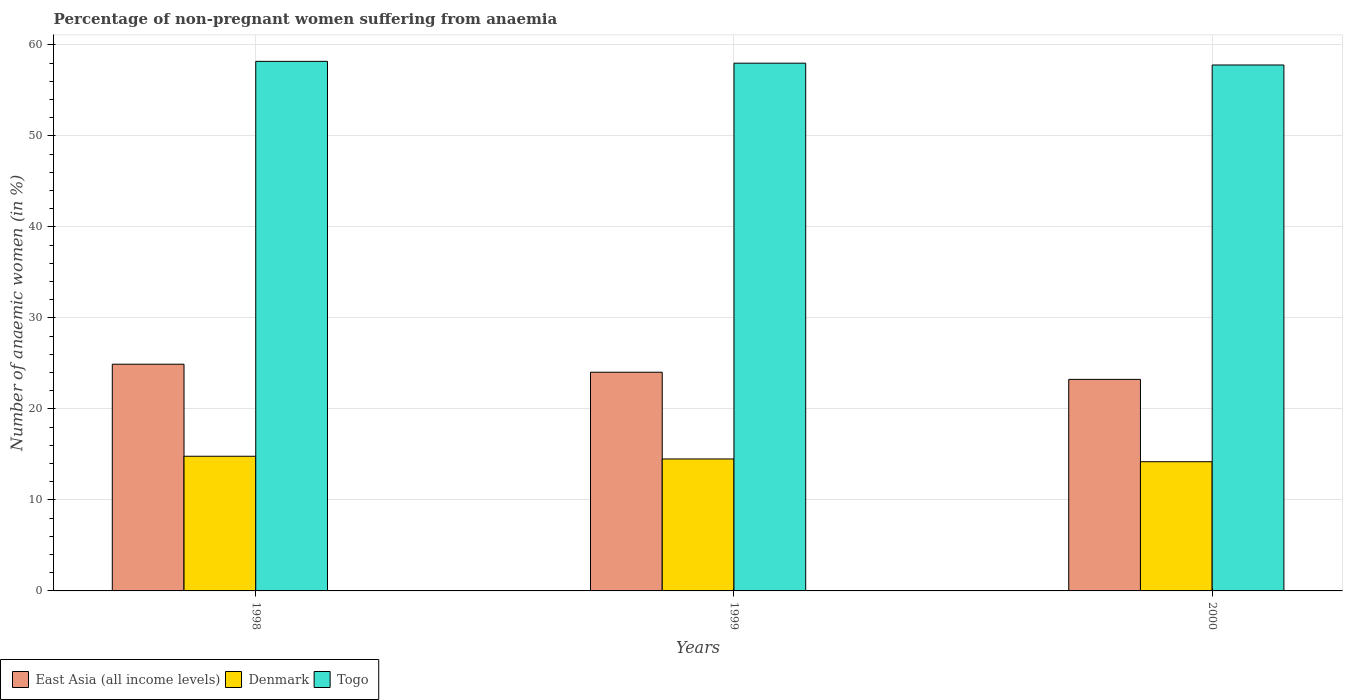How many different coloured bars are there?
Offer a very short reply. 3. How many groups of bars are there?
Your answer should be compact. 3. How many bars are there on the 3rd tick from the left?
Provide a succinct answer. 3. How many bars are there on the 1st tick from the right?
Provide a succinct answer. 3. In how many cases, is the number of bars for a given year not equal to the number of legend labels?
Your response must be concise. 0. What is the percentage of non-pregnant women suffering from anaemia in Togo in 1998?
Make the answer very short. 58.2. Across all years, what is the maximum percentage of non-pregnant women suffering from anaemia in Togo?
Give a very brief answer. 58.2. Across all years, what is the minimum percentage of non-pregnant women suffering from anaemia in East Asia (all income levels)?
Provide a succinct answer. 23.25. In which year was the percentage of non-pregnant women suffering from anaemia in East Asia (all income levels) maximum?
Give a very brief answer. 1998. What is the total percentage of non-pregnant women suffering from anaemia in East Asia (all income levels) in the graph?
Provide a short and direct response. 72.2. What is the difference between the percentage of non-pregnant women suffering from anaemia in Togo in 1998 and that in 2000?
Keep it short and to the point. 0.4. What is the difference between the percentage of non-pregnant women suffering from anaemia in Togo in 1998 and the percentage of non-pregnant women suffering from anaemia in Denmark in 1999?
Make the answer very short. 43.7. What is the average percentage of non-pregnant women suffering from anaemia in East Asia (all income levels) per year?
Your answer should be very brief. 24.07. In the year 1999, what is the difference between the percentage of non-pregnant women suffering from anaemia in Denmark and percentage of non-pregnant women suffering from anaemia in East Asia (all income levels)?
Ensure brevity in your answer.  -9.53. What is the ratio of the percentage of non-pregnant women suffering from anaemia in Togo in 1998 to that in 2000?
Offer a very short reply. 1.01. Is the difference between the percentage of non-pregnant women suffering from anaemia in Denmark in 1998 and 2000 greater than the difference between the percentage of non-pregnant women suffering from anaemia in East Asia (all income levels) in 1998 and 2000?
Keep it short and to the point. No. What is the difference between the highest and the second highest percentage of non-pregnant women suffering from anaemia in Denmark?
Provide a short and direct response. 0.3. What is the difference between the highest and the lowest percentage of non-pregnant women suffering from anaemia in Denmark?
Your answer should be very brief. 0.6. In how many years, is the percentage of non-pregnant women suffering from anaemia in East Asia (all income levels) greater than the average percentage of non-pregnant women suffering from anaemia in East Asia (all income levels) taken over all years?
Provide a short and direct response. 1. What does the 3rd bar from the left in 1998 represents?
Ensure brevity in your answer.  Togo. What does the 1st bar from the right in 1998 represents?
Offer a very short reply. Togo. How many bars are there?
Your answer should be compact. 9. Are all the bars in the graph horizontal?
Your response must be concise. No. How many years are there in the graph?
Provide a succinct answer. 3. What is the difference between two consecutive major ticks on the Y-axis?
Provide a succinct answer. 10. Does the graph contain any zero values?
Offer a terse response. No. Does the graph contain grids?
Offer a terse response. Yes. How many legend labels are there?
Ensure brevity in your answer.  3. What is the title of the graph?
Keep it short and to the point. Percentage of non-pregnant women suffering from anaemia. What is the label or title of the X-axis?
Ensure brevity in your answer.  Years. What is the label or title of the Y-axis?
Offer a very short reply. Number of anaemic women (in %). What is the Number of anaemic women (in %) in East Asia (all income levels) in 1998?
Provide a succinct answer. 24.92. What is the Number of anaemic women (in %) of Denmark in 1998?
Your response must be concise. 14.8. What is the Number of anaemic women (in %) in Togo in 1998?
Provide a succinct answer. 58.2. What is the Number of anaemic women (in %) of East Asia (all income levels) in 1999?
Keep it short and to the point. 24.03. What is the Number of anaemic women (in %) of East Asia (all income levels) in 2000?
Ensure brevity in your answer.  23.25. What is the Number of anaemic women (in %) in Denmark in 2000?
Your answer should be very brief. 14.2. What is the Number of anaemic women (in %) of Togo in 2000?
Your response must be concise. 57.8. Across all years, what is the maximum Number of anaemic women (in %) of East Asia (all income levels)?
Your answer should be compact. 24.92. Across all years, what is the maximum Number of anaemic women (in %) of Togo?
Ensure brevity in your answer.  58.2. Across all years, what is the minimum Number of anaemic women (in %) of East Asia (all income levels)?
Your response must be concise. 23.25. Across all years, what is the minimum Number of anaemic women (in %) of Togo?
Ensure brevity in your answer.  57.8. What is the total Number of anaemic women (in %) of East Asia (all income levels) in the graph?
Provide a succinct answer. 72.2. What is the total Number of anaemic women (in %) in Denmark in the graph?
Provide a short and direct response. 43.5. What is the total Number of anaemic women (in %) of Togo in the graph?
Your answer should be very brief. 174. What is the difference between the Number of anaemic women (in %) of East Asia (all income levels) in 1998 and that in 1999?
Provide a short and direct response. 0.88. What is the difference between the Number of anaemic women (in %) of East Asia (all income levels) in 1998 and that in 2000?
Your response must be concise. 1.67. What is the difference between the Number of anaemic women (in %) in Denmark in 1998 and that in 2000?
Provide a succinct answer. 0.6. What is the difference between the Number of anaemic women (in %) in Togo in 1998 and that in 2000?
Give a very brief answer. 0.4. What is the difference between the Number of anaemic women (in %) of East Asia (all income levels) in 1999 and that in 2000?
Offer a terse response. 0.79. What is the difference between the Number of anaemic women (in %) of Togo in 1999 and that in 2000?
Provide a short and direct response. 0.2. What is the difference between the Number of anaemic women (in %) of East Asia (all income levels) in 1998 and the Number of anaemic women (in %) of Denmark in 1999?
Offer a terse response. 10.42. What is the difference between the Number of anaemic women (in %) of East Asia (all income levels) in 1998 and the Number of anaemic women (in %) of Togo in 1999?
Ensure brevity in your answer.  -33.08. What is the difference between the Number of anaemic women (in %) in Denmark in 1998 and the Number of anaemic women (in %) in Togo in 1999?
Make the answer very short. -43.2. What is the difference between the Number of anaemic women (in %) of East Asia (all income levels) in 1998 and the Number of anaemic women (in %) of Denmark in 2000?
Make the answer very short. 10.72. What is the difference between the Number of anaemic women (in %) of East Asia (all income levels) in 1998 and the Number of anaemic women (in %) of Togo in 2000?
Keep it short and to the point. -32.88. What is the difference between the Number of anaemic women (in %) of Denmark in 1998 and the Number of anaemic women (in %) of Togo in 2000?
Keep it short and to the point. -43. What is the difference between the Number of anaemic women (in %) of East Asia (all income levels) in 1999 and the Number of anaemic women (in %) of Denmark in 2000?
Make the answer very short. 9.83. What is the difference between the Number of anaemic women (in %) of East Asia (all income levels) in 1999 and the Number of anaemic women (in %) of Togo in 2000?
Provide a succinct answer. -33.77. What is the difference between the Number of anaemic women (in %) of Denmark in 1999 and the Number of anaemic women (in %) of Togo in 2000?
Your response must be concise. -43.3. What is the average Number of anaemic women (in %) in East Asia (all income levels) per year?
Offer a very short reply. 24.07. What is the average Number of anaemic women (in %) in Denmark per year?
Your answer should be very brief. 14.5. What is the average Number of anaemic women (in %) in Togo per year?
Your response must be concise. 58. In the year 1998, what is the difference between the Number of anaemic women (in %) of East Asia (all income levels) and Number of anaemic women (in %) of Denmark?
Provide a short and direct response. 10.12. In the year 1998, what is the difference between the Number of anaemic women (in %) in East Asia (all income levels) and Number of anaemic women (in %) in Togo?
Offer a terse response. -33.28. In the year 1998, what is the difference between the Number of anaemic women (in %) of Denmark and Number of anaemic women (in %) of Togo?
Make the answer very short. -43.4. In the year 1999, what is the difference between the Number of anaemic women (in %) of East Asia (all income levels) and Number of anaemic women (in %) of Denmark?
Give a very brief answer. 9.53. In the year 1999, what is the difference between the Number of anaemic women (in %) of East Asia (all income levels) and Number of anaemic women (in %) of Togo?
Offer a terse response. -33.97. In the year 1999, what is the difference between the Number of anaemic women (in %) of Denmark and Number of anaemic women (in %) of Togo?
Give a very brief answer. -43.5. In the year 2000, what is the difference between the Number of anaemic women (in %) of East Asia (all income levels) and Number of anaemic women (in %) of Denmark?
Give a very brief answer. 9.05. In the year 2000, what is the difference between the Number of anaemic women (in %) of East Asia (all income levels) and Number of anaemic women (in %) of Togo?
Your answer should be compact. -34.55. In the year 2000, what is the difference between the Number of anaemic women (in %) of Denmark and Number of anaemic women (in %) of Togo?
Your answer should be compact. -43.6. What is the ratio of the Number of anaemic women (in %) of East Asia (all income levels) in 1998 to that in 1999?
Make the answer very short. 1.04. What is the ratio of the Number of anaemic women (in %) in Denmark in 1998 to that in 1999?
Offer a very short reply. 1.02. What is the ratio of the Number of anaemic women (in %) in East Asia (all income levels) in 1998 to that in 2000?
Your response must be concise. 1.07. What is the ratio of the Number of anaemic women (in %) in Denmark in 1998 to that in 2000?
Your response must be concise. 1.04. What is the ratio of the Number of anaemic women (in %) of East Asia (all income levels) in 1999 to that in 2000?
Provide a short and direct response. 1.03. What is the ratio of the Number of anaemic women (in %) of Denmark in 1999 to that in 2000?
Your answer should be compact. 1.02. What is the ratio of the Number of anaemic women (in %) of Togo in 1999 to that in 2000?
Your response must be concise. 1. What is the difference between the highest and the second highest Number of anaemic women (in %) in East Asia (all income levels)?
Provide a short and direct response. 0.88. What is the difference between the highest and the second highest Number of anaemic women (in %) in Denmark?
Provide a short and direct response. 0.3. What is the difference between the highest and the second highest Number of anaemic women (in %) in Togo?
Provide a short and direct response. 0.2. What is the difference between the highest and the lowest Number of anaemic women (in %) in East Asia (all income levels)?
Offer a terse response. 1.67. 